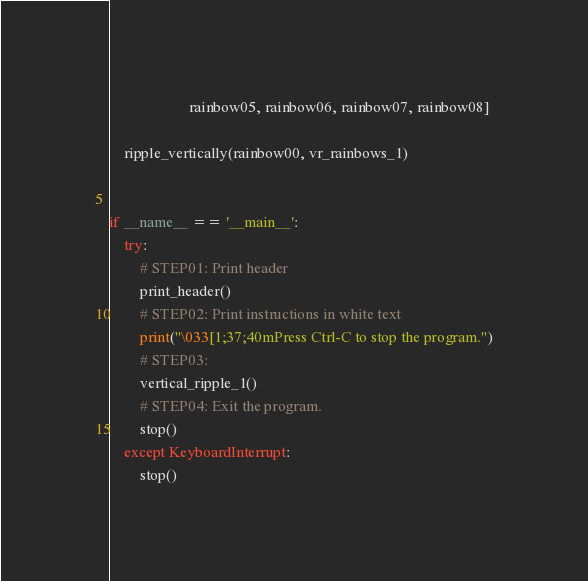<code> <loc_0><loc_0><loc_500><loc_500><_Python_>                     rainbow05, rainbow06, rainbow07, rainbow08]

    ripple_vertically(rainbow00, vr_rainbows_1)


if __name__ == '__main__':
    try:
        # STEP01: Print header
        print_header()
        # STEP02: Print instructions in white text
        print("\033[1;37;40mPress Ctrl-C to stop the program.")
        # STEP03:
        vertical_ripple_1()
        # STEP04: Exit the program.
        stop()
    except KeyboardInterrupt:
        stop()
</code> 